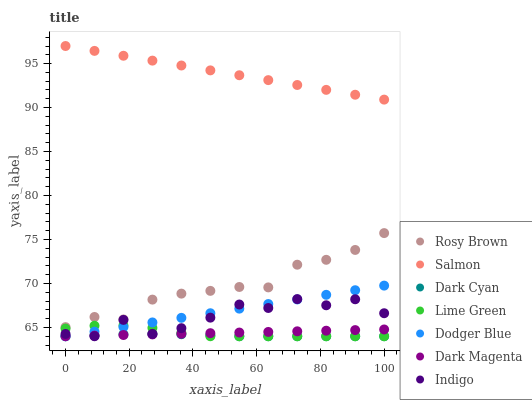Does Dark Cyan have the minimum area under the curve?
Answer yes or no. Yes. Does Salmon have the maximum area under the curve?
Answer yes or no. Yes. Does Dark Magenta have the minimum area under the curve?
Answer yes or no. No. Does Dark Magenta have the maximum area under the curve?
Answer yes or no. No. Is Dodger Blue the smoothest?
Answer yes or no. Yes. Is Indigo the roughest?
Answer yes or no. Yes. Is Dark Magenta the smoothest?
Answer yes or no. No. Is Dark Magenta the roughest?
Answer yes or no. No. Does Indigo have the lowest value?
Answer yes or no. Yes. Does Rosy Brown have the lowest value?
Answer yes or no. No. Does Salmon have the highest value?
Answer yes or no. Yes. Does Dark Magenta have the highest value?
Answer yes or no. No. Is Dodger Blue less than Rosy Brown?
Answer yes or no. Yes. Is Salmon greater than Lime Green?
Answer yes or no. Yes. Does Dark Cyan intersect Lime Green?
Answer yes or no. Yes. Is Dark Cyan less than Lime Green?
Answer yes or no. No. Is Dark Cyan greater than Lime Green?
Answer yes or no. No. Does Dodger Blue intersect Rosy Brown?
Answer yes or no. No. 